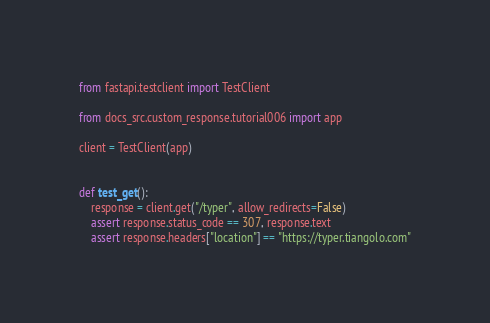<code> <loc_0><loc_0><loc_500><loc_500><_Python_>from fastapi.testclient import TestClient

from docs_src.custom_response.tutorial006 import app

client = TestClient(app)


def test_get():
    response = client.get("/typer", allow_redirects=False)
    assert response.status_code == 307, response.text
    assert response.headers["location"] == "https://typer.tiangolo.com"
</code> 